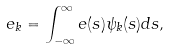<formula> <loc_0><loc_0><loc_500><loc_500>e _ { k } = \int _ { - \infty } ^ { \infty } e ( s ) \psi _ { k } ( s ) d s ,</formula> 